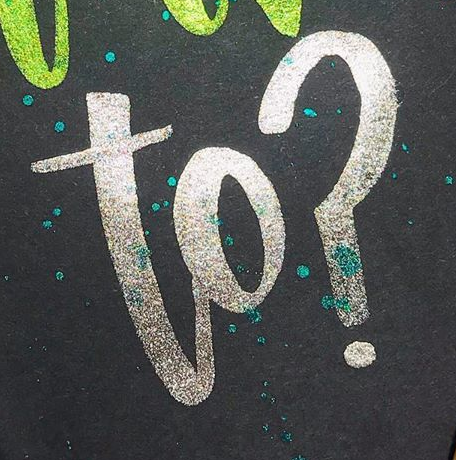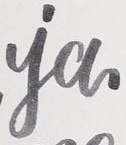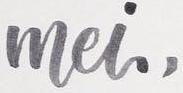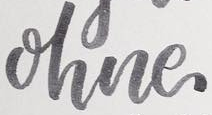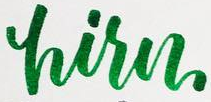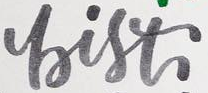Identify the words shown in these images in order, separated by a semicolon. to?; ia; mei,; ohne; hisn; bist 